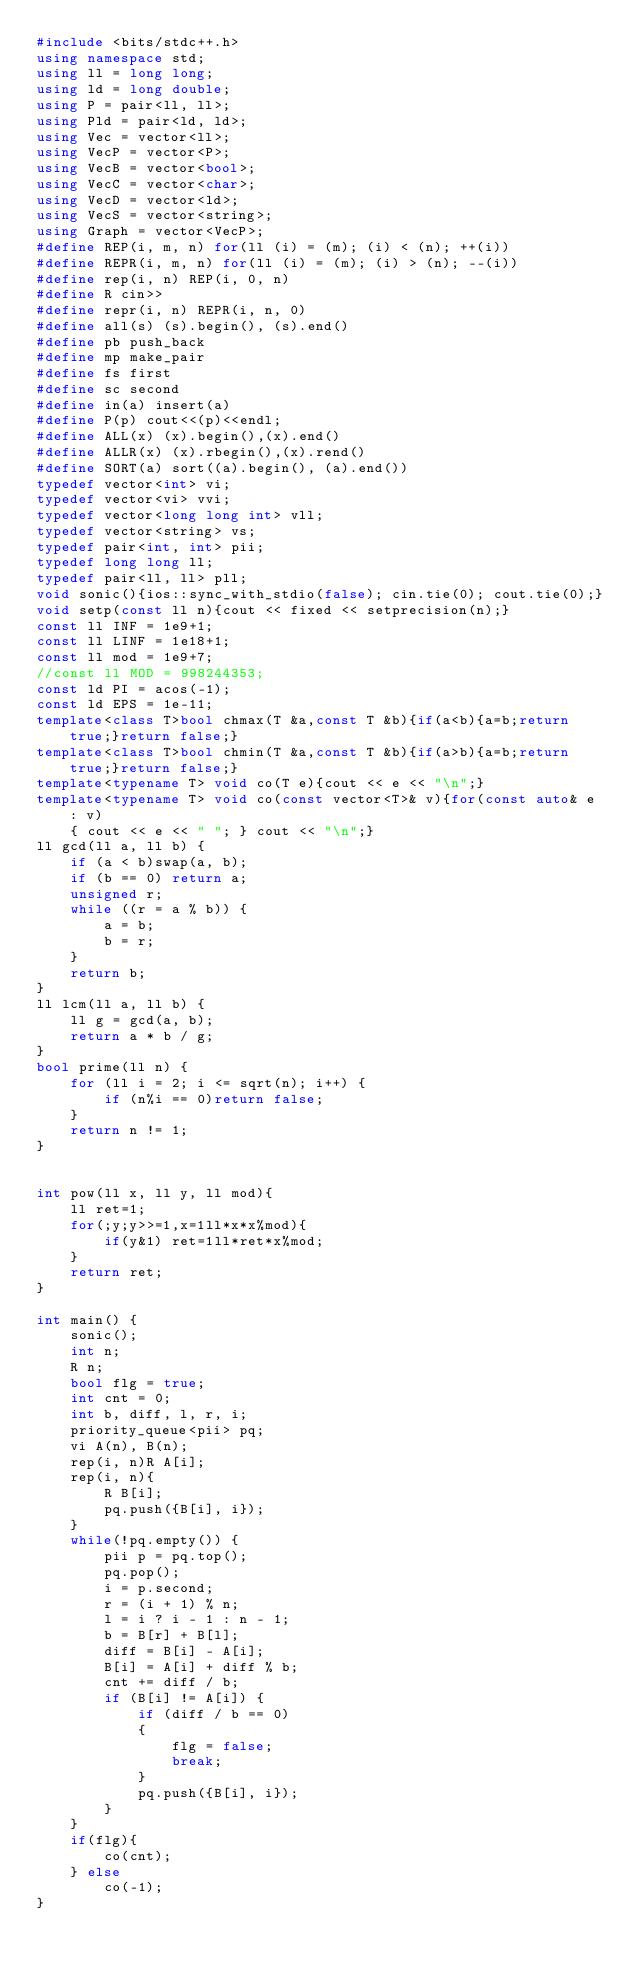Convert code to text. <code><loc_0><loc_0><loc_500><loc_500><_C++_>#include <bits/stdc++.h>
using namespace std;
using ll = long long;
using ld = long double;
using P = pair<ll, ll>;
using Pld = pair<ld, ld>;
using Vec = vector<ll>;
using VecP = vector<P>;
using VecB = vector<bool>;
using VecC = vector<char>;
using VecD = vector<ld>;
using VecS = vector<string>;
using Graph = vector<VecP>;
#define REP(i, m, n) for(ll (i) = (m); (i) < (n); ++(i))
#define REPR(i, m, n) for(ll (i) = (m); (i) > (n); --(i))
#define rep(i, n) REP(i, 0, n)
#define R cin>>
#define repr(i, n) REPR(i, n, 0)
#define all(s) (s).begin(), (s).end()
#define pb push_back
#define mp make_pair
#define fs first
#define sc second
#define in(a) insert(a)
#define P(p) cout<<(p)<<endl;
#define ALL(x) (x).begin(),(x).end()
#define ALLR(x) (x).rbegin(),(x).rend()
#define SORT(a) sort((a).begin(), (a).end())
typedef vector<int> vi;
typedef vector<vi> vvi;
typedef vector<long long int> vll;
typedef vector<string> vs;
typedef pair<int, int> pii;
typedef long long ll;
typedef pair<ll, ll> pll;
void sonic(){ios::sync_with_stdio(false); cin.tie(0); cout.tie(0);}
void setp(const ll n){cout << fixed << setprecision(n);}
const ll INF = 1e9+1;
const ll LINF = 1e18+1;
const ll mod = 1e9+7;
//const ll MOD = 998244353;
const ld PI = acos(-1);
const ld EPS = 1e-11;
template<class T>bool chmax(T &a,const T &b){if(a<b){a=b;return true;}return false;}
template<class T>bool chmin(T &a,const T &b){if(a>b){a=b;return true;}return false;}
template<typename T> void co(T e){cout << e << "\n";}
template<typename T> void co(const vector<T>& v){for(const auto& e : v)
    { cout << e << " "; } cout << "\n";}
ll gcd(ll a, ll b) {
    if (a < b)swap(a, b);
    if (b == 0) return a;
    unsigned r;
    while ((r = a % b)) {
        a = b;
        b = r;
    }
    return b;
}
ll lcm(ll a, ll b) {
    ll g = gcd(a, b);
    return a * b / g;
}
bool prime(ll n) {
    for (ll i = 2; i <= sqrt(n); i++) {
        if (n%i == 0)return false;
    }
    return n != 1;
}


int pow(ll x, ll y, ll mod){
    ll ret=1;
    for(;y;y>>=1,x=1ll*x*x%mod){
        if(y&1) ret=1ll*ret*x%mod;
    }
    return ret;
}

int main() {
    sonic();
    int n;
    R n;
    bool flg = true;
    int cnt = 0;
    int b, diff, l, r, i;
    priority_queue<pii> pq;
    vi A(n), B(n);
    rep(i, n)R A[i];
    rep(i, n){
        R B[i];
        pq.push({B[i], i});
    }
    while(!pq.empty()) {
        pii p = pq.top();
        pq.pop();
        i = p.second;
        r = (i + 1) % n;
        l = i ? i - 1 : n - 1;
        b = B[r] + B[l];
        diff = B[i] - A[i];
        B[i] = A[i] + diff % b;
        cnt += diff / b;
        if (B[i] != A[i]) {
            if (diff / b == 0)
            {
                flg = false;
                break;
            }
            pq.push({B[i], i});
        }
    }
    if(flg){
        co(cnt);
    } else
        co(-1);
}
</code> 